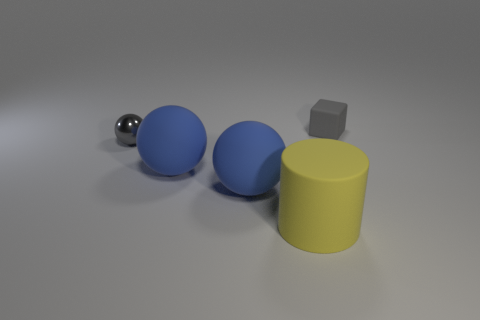Add 1 cylinders. How many objects exist? 6 Subtract all cubes. How many objects are left? 4 Add 5 big yellow matte things. How many big yellow matte things exist? 6 Subtract 0 green cylinders. How many objects are left? 5 Subtract all rubber balls. Subtract all large matte objects. How many objects are left? 0 Add 5 large yellow matte cylinders. How many large yellow matte cylinders are left? 6 